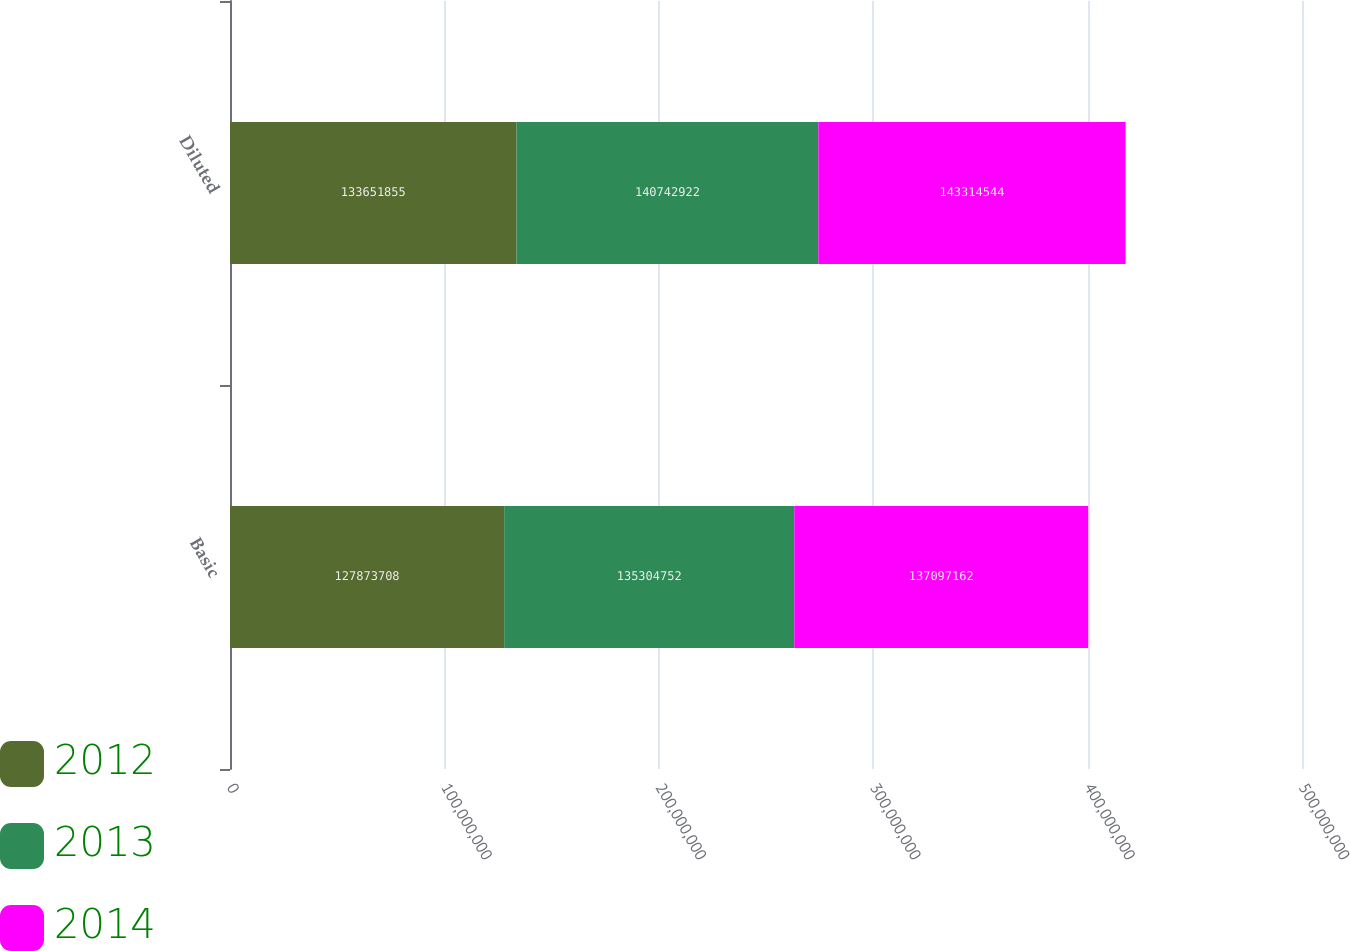Convert chart to OTSL. <chart><loc_0><loc_0><loc_500><loc_500><stacked_bar_chart><ecel><fcel>Basic<fcel>Diluted<nl><fcel>2012<fcel>1.27874e+08<fcel>1.33652e+08<nl><fcel>2013<fcel>1.35305e+08<fcel>1.40743e+08<nl><fcel>2014<fcel>1.37097e+08<fcel>1.43315e+08<nl></chart> 